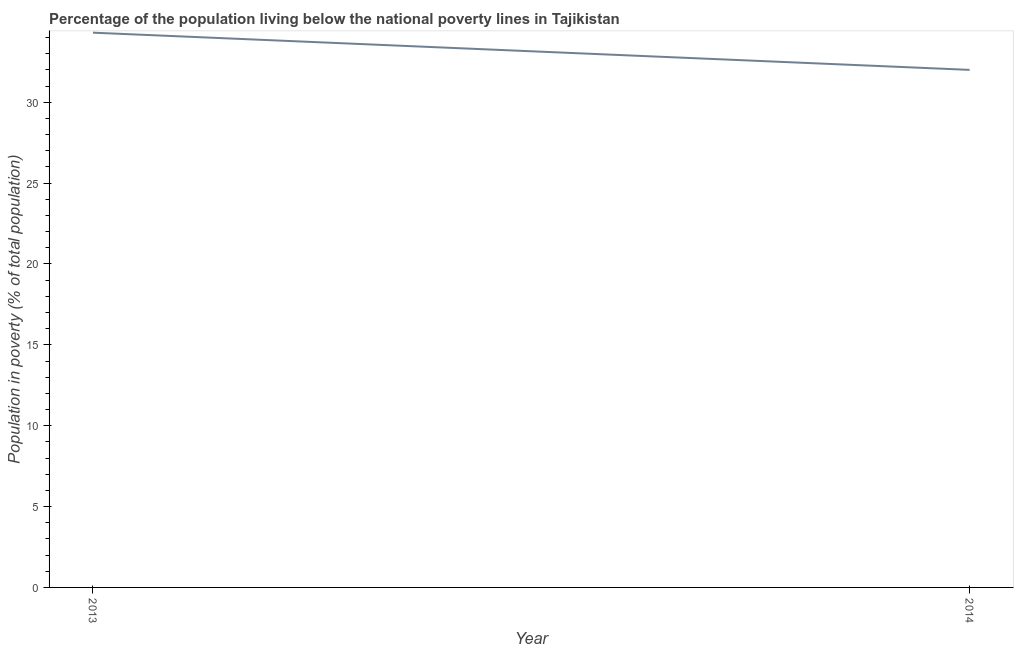What is the percentage of population living below poverty line in 2013?
Keep it short and to the point. 34.3. Across all years, what is the maximum percentage of population living below poverty line?
Offer a very short reply. 34.3. What is the sum of the percentage of population living below poverty line?
Give a very brief answer. 66.3. What is the difference between the percentage of population living below poverty line in 2013 and 2014?
Provide a short and direct response. 2.3. What is the average percentage of population living below poverty line per year?
Provide a succinct answer. 33.15. What is the median percentage of population living below poverty line?
Provide a short and direct response. 33.15. What is the ratio of the percentage of population living below poverty line in 2013 to that in 2014?
Ensure brevity in your answer.  1.07. Is the percentage of population living below poverty line in 2013 less than that in 2014?
Offer a terse response. No. Does the percentage of population living below poverty line monotonically increase over the years?
Your answer should be very brief. No. What is the difference between two consecutive major ticks on the Y-axis?
Keep it short and to the point. 5. What is the title of the graph?
Make the answer very short. Percentage of the population living below the national poverty lines in Tajikistan. What is the label or title of the X-axis?
Give a very brief answer. Year. What is the label or title of the Y-axis?
Keep it short and to the point. Population in poverty (% of total population). What is the Population in poverty (% of total population) of 2013?
Give a very brief answer. 34.3. What is the difference between the Population in poverty (% of total population) in 2013 and 2014?
Offer a terse response. 2.3. What is the ratio of the Population in poverty (% of total population) in 2013 to that in 2014?
Your answer should be compact. 1.07. 